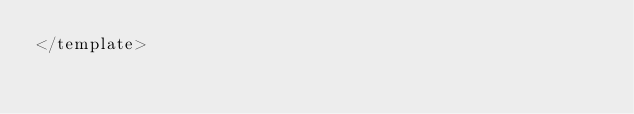Convert code to text. <code><loc_0><loc_0><loc_500><loc_500><_HTML_></template>
</code> 